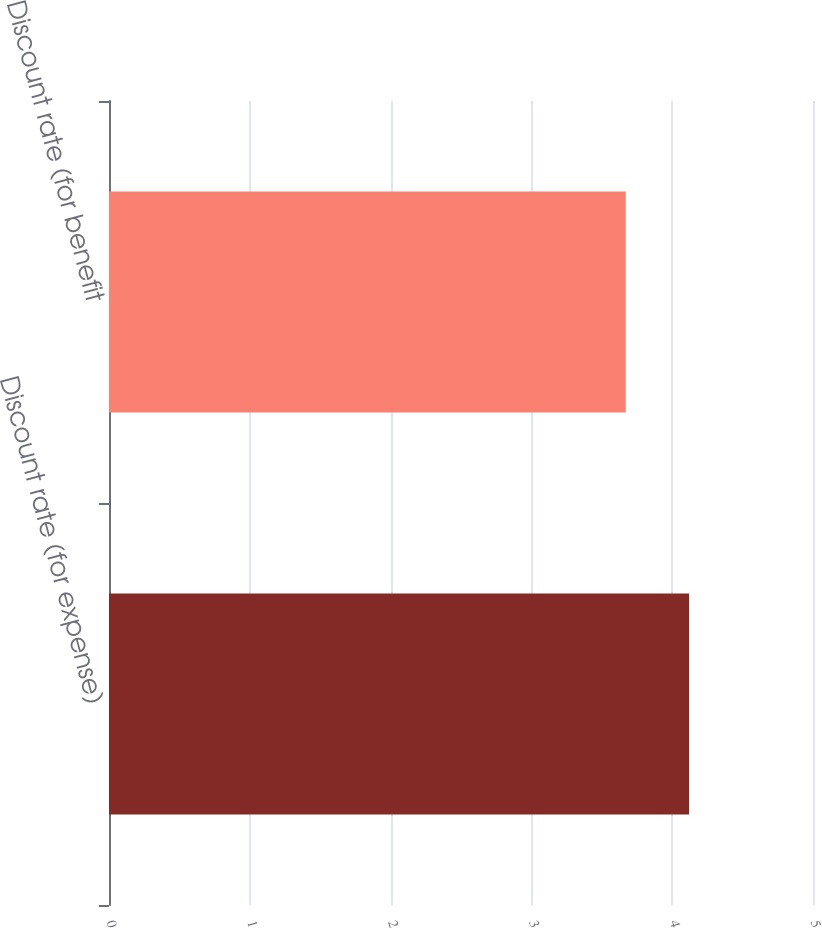Convert chart. <chart><loc_0><loc_0><loc_500><loc_500><bar_chart><fcel>Discount rate (for expense)<fcel>Discount rate (for benefit<nl><fcel>4.12<fcel>3.67<nl></chart> 